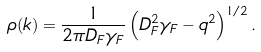Convert formula to latex. <formula><loc_0><loc_0><loc_500><loc_500>\rho ( k ) = \frac { 1 } { 2 \pi D _ { F } \gamma _ { F } } \left ( D _ { F } ^ { 2 } \gamma _ { F } - q ^ { 2 } \right ) ^ { 1 / 2 } .</formula> 